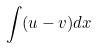<formula> <loc_0><loc_0><loc_500><loc_500>\int ( u - v ) d x</formula> 